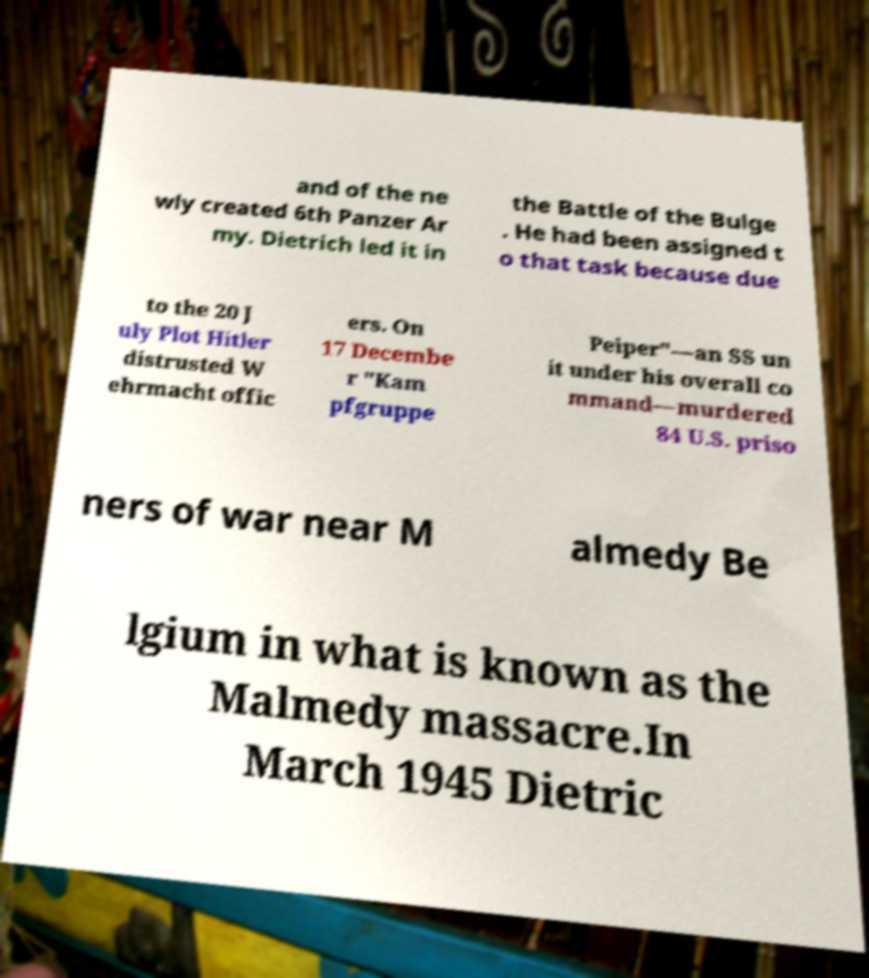I need the written content from this picture converted into text. Can you do that? and of the ne wly created 6th Panzer Ar my. Dietrich led it in the Battle of the Bulge . He had been assigned t o that task because due to the 20 J uly Plot Hitler distrusted W ehrmacht offic ers. On 17 Decembe r "Kam pfgruppe Peiper"—an SS un it under his overall co mmand—murdered 84 U.S. priso ners of war near M almedy Be lgium in what is known as the Malmedy massacre.In March 1945 Dietric 